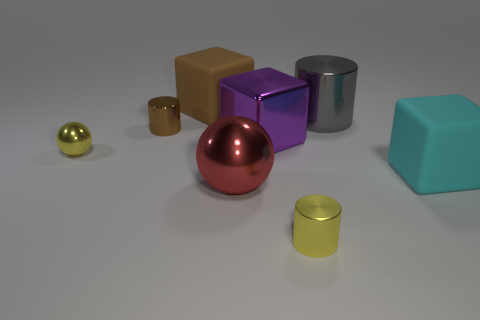Subtract all big shiny cylinders. How many cylinders are left? 2 Add 2 small cylinders. How many objects exist? 10 Subtract all spheres. How many objects are left? 6 Subtract all cyan cylinders. Subtract all green spheres. How many cylinders are left? 3 Add 6 large gray shiny objects. How many large gray shiny objects exist? 7 Subtract 0 purple cylinders. How many objects are left? 8 Subtract all large things. Subtract all tiny brown metallic cylinders. How many objects are left? 2 Add 3 tiny yellow things. How many tiny yellow things are left? 5 